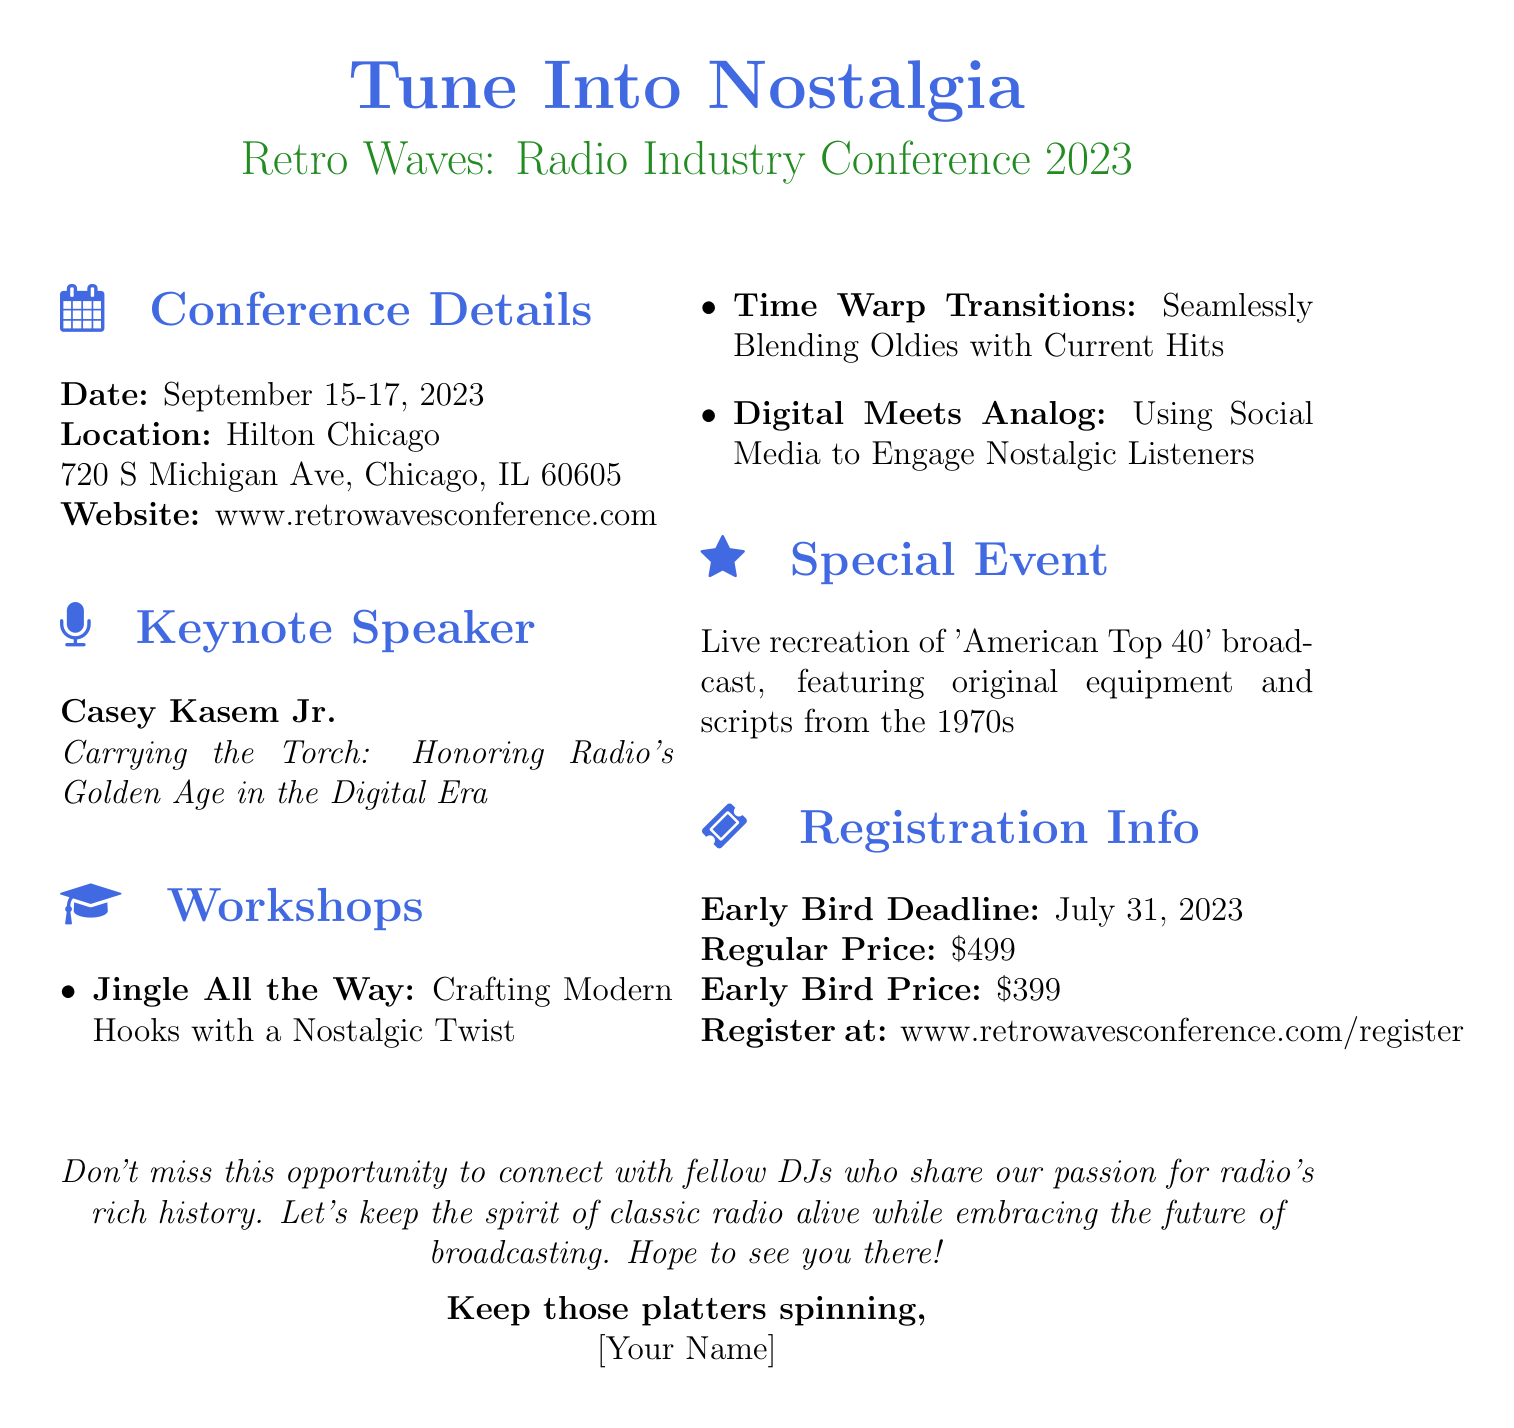What is the name of the conference? The document mentions the conference name as "Retro Waves: Radio Industry Conference 2023."
Answer: Retro Waves: Radio Industry Conference 2023 What are the dates of the conference? The document states that the conference will take place on September 15-17, 2023.
Answer: September 15-17, 2023 Who is the keynote speaker? According to the document, the keynote speaker is Casey Kasem Jr.
Answer: Casey Kasem Jr What is the topic of the keynote speech? The document specifies that the keynote speech will be on "Carrying the Torch: Honoring Radio's Golden Age in the Digital Era."
Answer: Carrying the Torch: Honoring Radio's Golden Age in the Digital Era What is the early bird registration price? The early bird price mentioned in the document is $399.
Answer: $399 Which workshop focuses on social media? The document includes a workshop titled "Digital Meets Analog: Using Social Media to Engage Nostalgic Listeners."
Answer: Digital Meets Analog: Using Social Media to Engage Nostalgic Listeners What special event will take place during the conference? The document indicates that there will be a live recreation of the "American Top 40" broadcast.
Answer: Live recreation of 'American Top 40' broadcast By when should participants register for early bird pricing? The document states the early bird deadline is July 31, 2023.
Answer: July 31, 2023 Where is the conference being held? According to the document, the venue for the conference is Hilton Chicago.
Answer: Hilton Chicago 